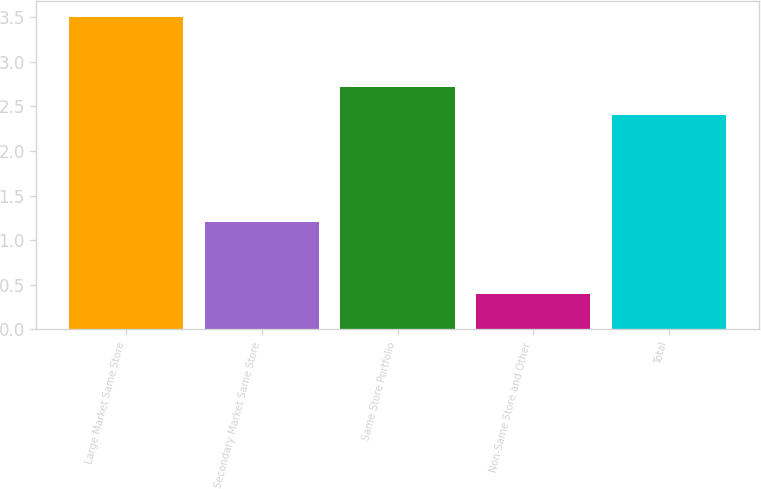<chart> <loc_0><loc_0><loc_500><loc_500><bar_chart><fcel>Large Market Same Store<fcel>Secondary Market Same Store<fcel>Same Store Portfolio<fcel>Non-Same Store and Other<fcel>Total<nl><fcel>3.5<fcel>1.2<fcel>2.71<fcel>0.4<fcel>2.4<nl></chart> 